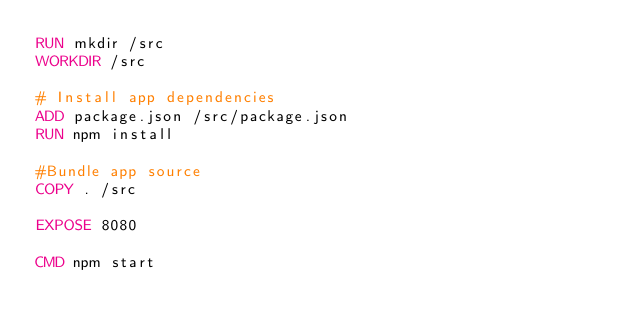<code> <loc_0><loc_0><loc_500><loc_500><_Dockerfile_>RUN mkdir /src
WORKDIR /src

# Install app dependencies
ADD package.json /src/package.json
RUN npm install

#Bundle app source
COPY . /src

EXPOSE 8080

CMD npm start
</code> 